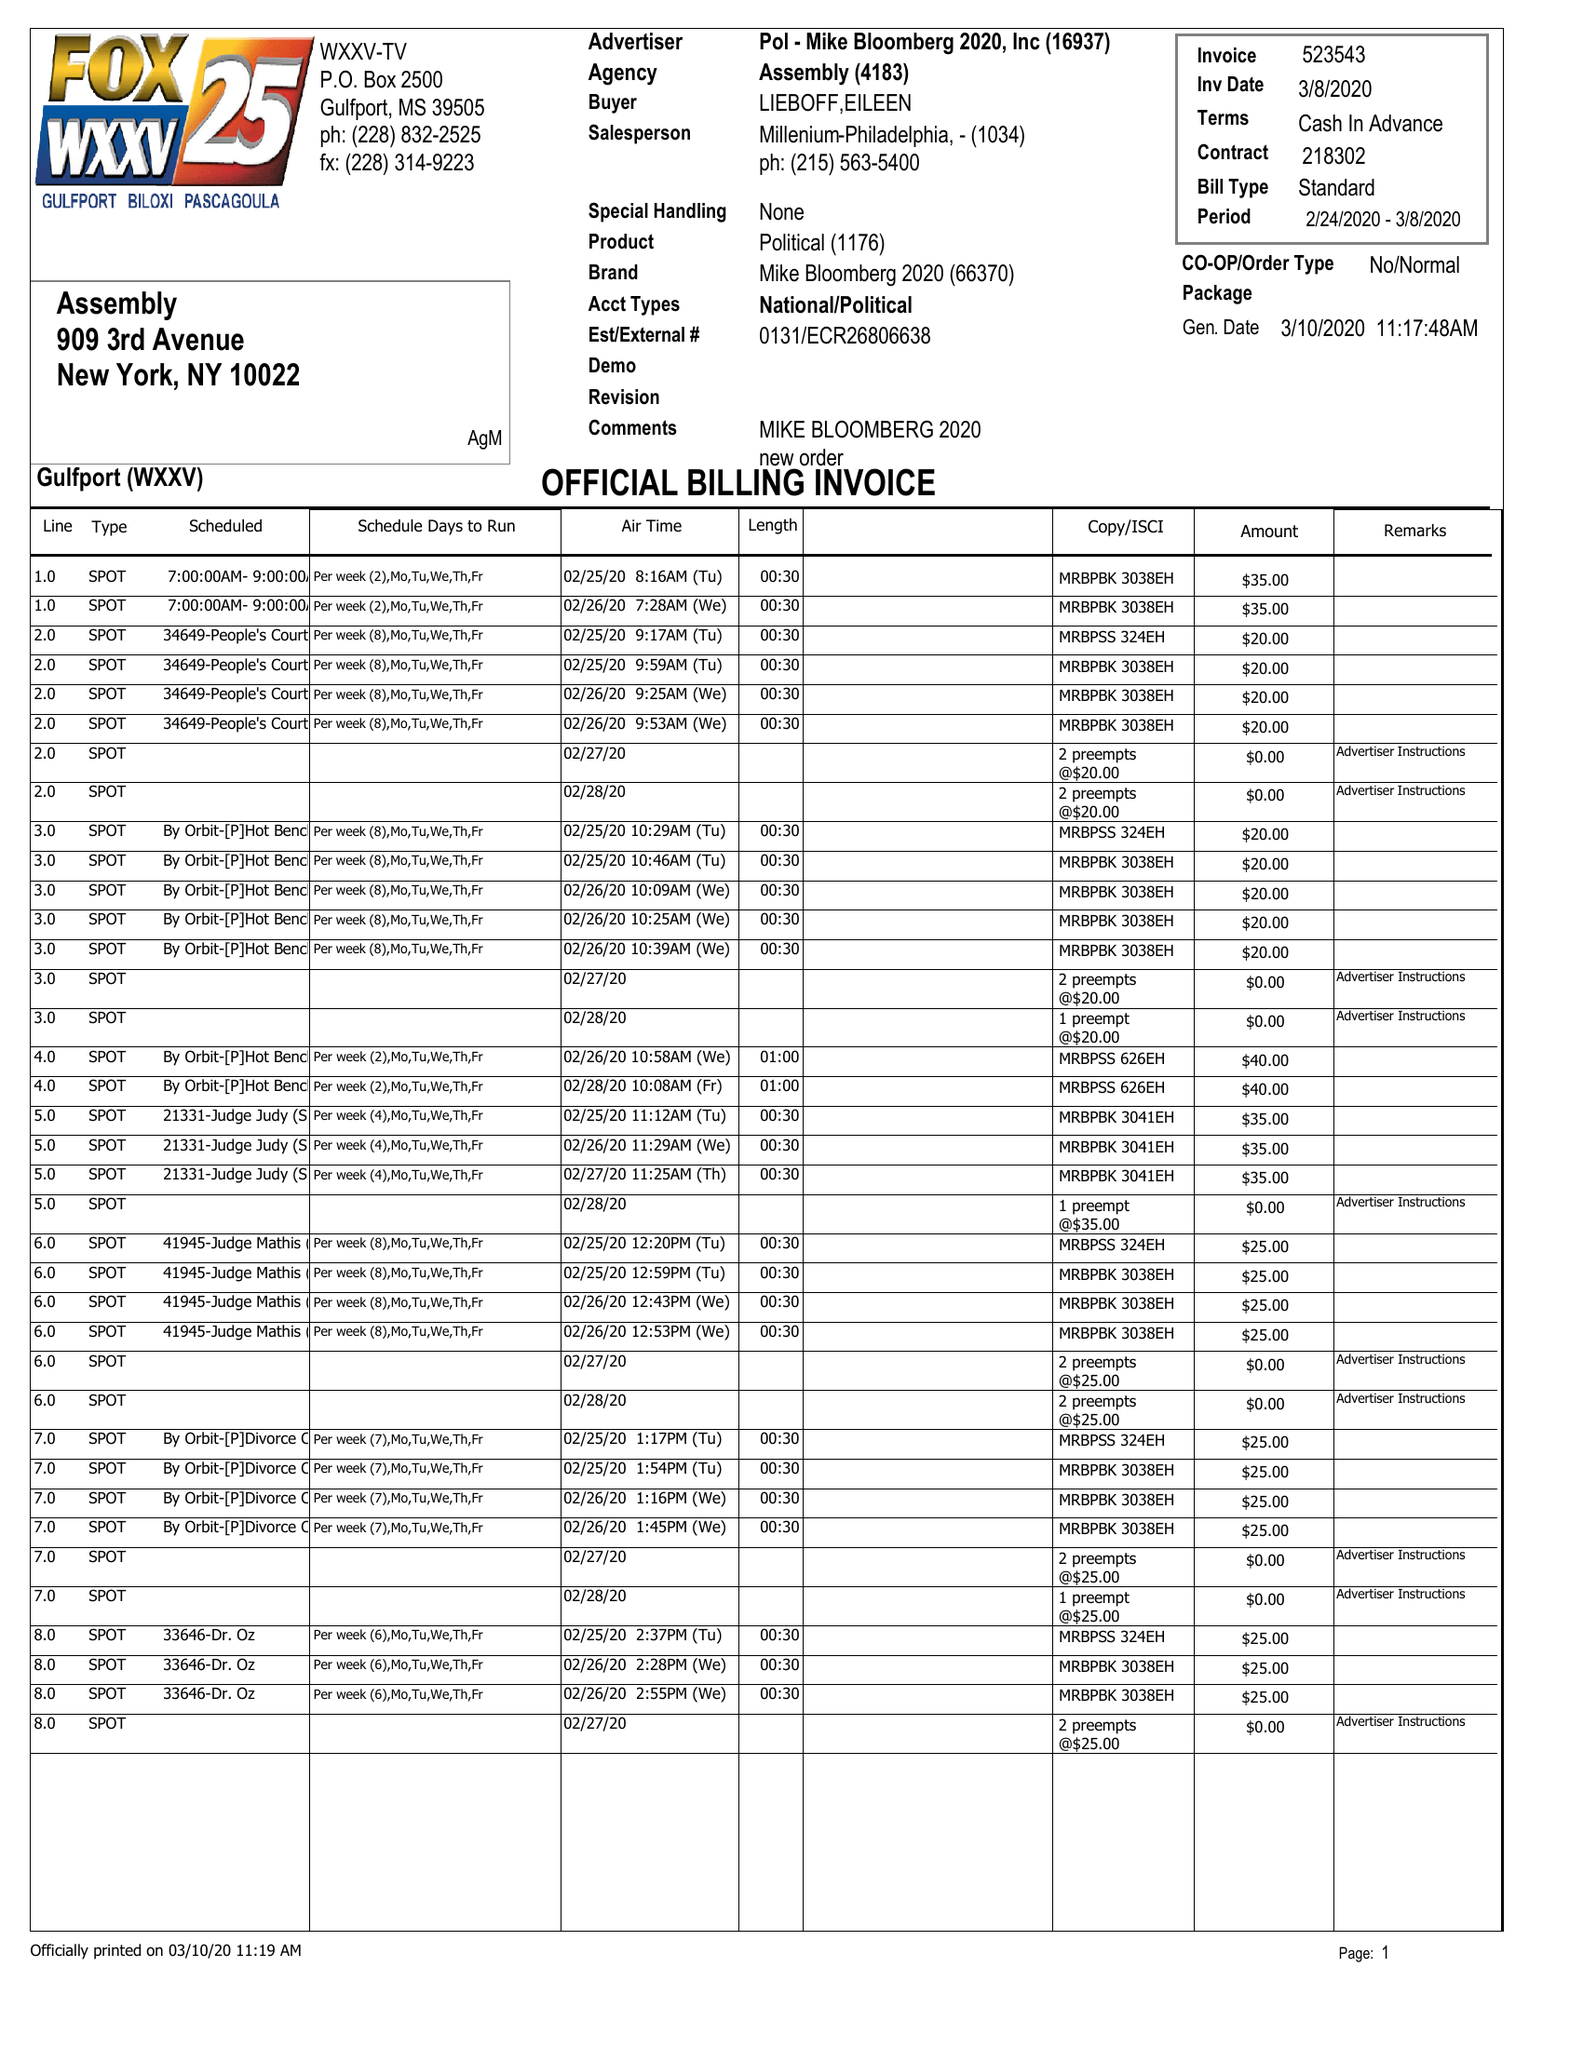What is the value for the contract_num?
Answer the question using a single word or phrase. 218302 